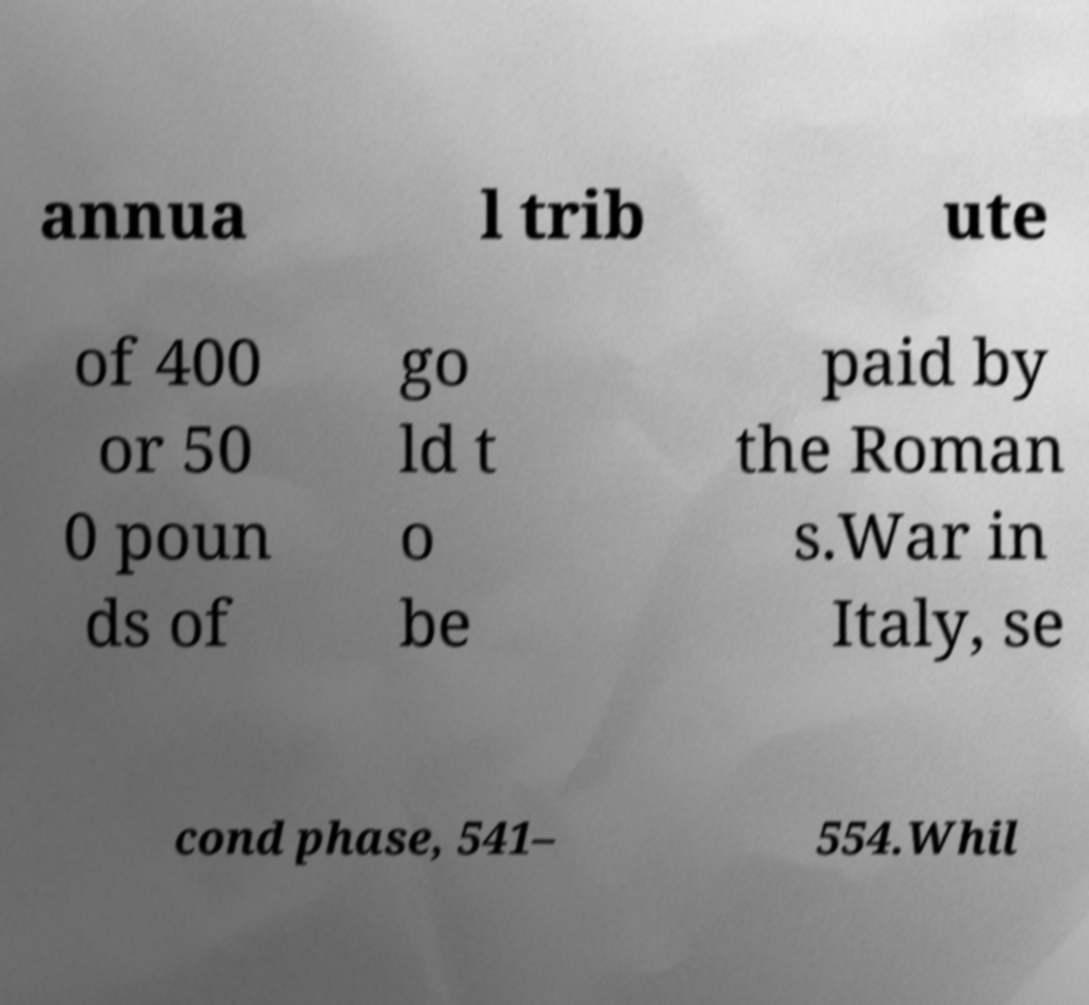What messages or text are displayed in this image? I need them in a readable, typed format. annua l trib ute of 400 or 50 0 poun ds of go ld t o be paid by the Roman s.War in Italy, se cond phase, 541– 554.Whil 